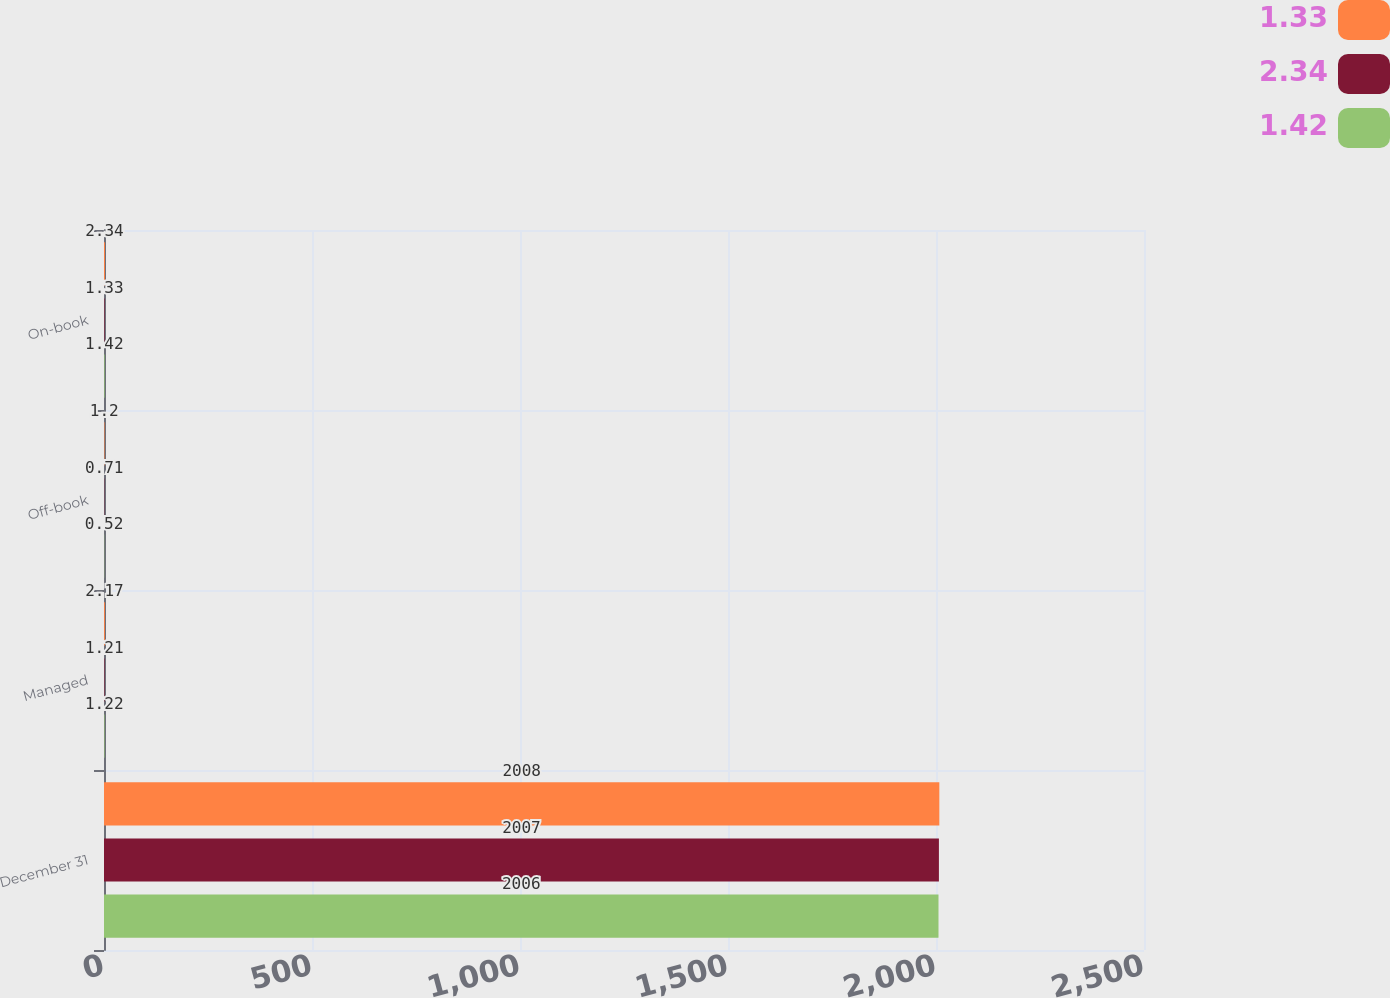<chart> <loc_0><loc_0><loc_500><loc_500><stacked_bar_chart><ecel><fcel>December 31<fcel>Managed<fcel>Off-book<fcel>On-book<nl><fcel>1.33<fcel>2008<fcel>2.17<fcel>1.2<fcel>2.34<nl><fcel>2.34<fcel>2007<fcel>1.21<fcel>0.71<fcel>1.33<nl><fcel>1.42<fcel>2006<fcel>1.22<fcel>0.52<fcel>1.42<nl></chart> 